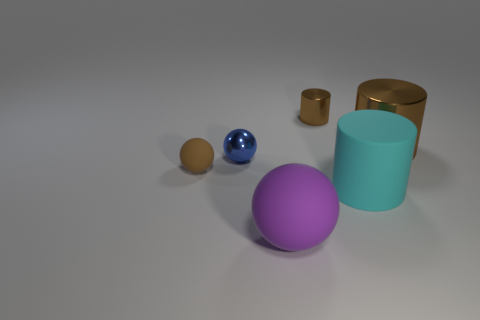Subtract all small balls. How many balls are left? 1 Subtract 1 cylinders. How many cylinders are left? 2 Add 4 purple matte balls. How many objects exist? 10 Add 5 big brown metal cylinders. How many big brown metal cylinders exist? 6 Subtract 0 cyan balls. How many objects are left? 6 Subtract all big red cubes. Subtract all cyan objects. How many objects are left? 5 Add 4 small brown shiny things. How many small brown shiny things are left? 5 